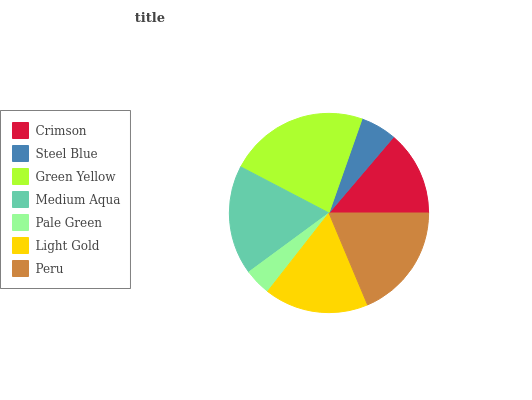Is Pale Green the minimum?
Answer yes or no. Yes. Is Green Yellow the maximum?
Answer yes or no. Yes. Is Steel Blue the minimum?
Answer yes or no. No. Is Steel Blue the maximum?
Answer yes or no. No. Is Crimson greater than Steel Blue?
Answer yes or no. Yes. Is Steel Blue less than Crimson?
Answer yes or no. Yes. Is Steel Blue greater than Crimson?
Answer yes or no. No. Is Crimson less than Steel Blue?
Answer yes or no. No. Is Light Gold the high median?
Answer yes or no. Yes. Is Light Gold the low median?
Answer yes or no. Yes. Is Peru the high median?
Answer yes or no. No. Is Medium Aqua the low median?
Answer yes or no. No. 